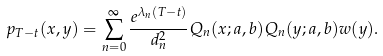<formula> <loc_0><loc_0><loc_500><loc_500>p _ { T - t } ( x , y ) = \sum _ { n = 0 } ^ { \infty } \frac { e ^ { \lambda _ { n } ( T - t ) } } { d _ { n } ^ { 2 } } Q _ { n } ( x ; a , b ) Q _ { n } ( y ; a , b ) w ( y ) .</formula> 